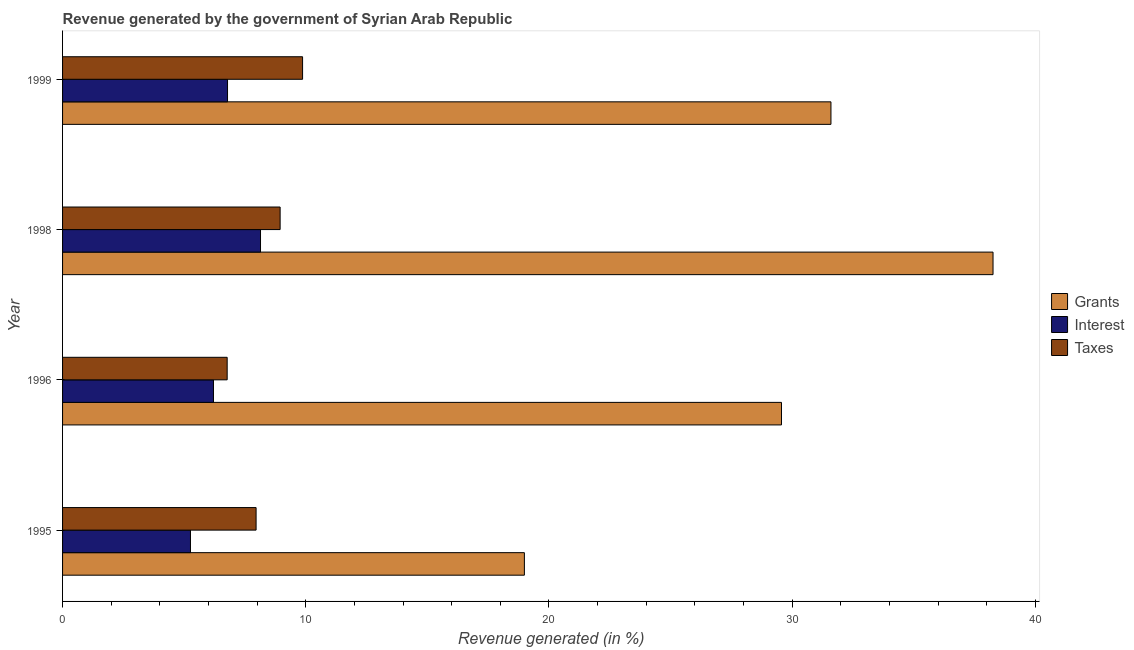Are the number of bars per tick equal to the number of legend labels?
Make the answer very short. Yes. What is the label of the 4th group of bars from the top?
Give a very brief answer. 1995. What is the percentage of revenue generated by taxes in 1998?
Make the answer very short. 8.95. Across all years, what is the maximum percentage of revenue generated by taxes?
Your answer should be compact. 9.87. Across all years, what is the minimum percentage of revenue generated by taxes?
Your answer should be compact. 6.77. In which year was the percentage of revenue generated by taxes maximum?
Give a very brief answer. 1999. What is the total percentage of revenue generated by interest in the graph?
Your answer should be compact. 26.39. What is the difference between the percentage of revenue generated by interest in 1996 and that in 1998?
Your answer should be compact. -1.93. What is the difference between the percentage of revenue generated by interest in 1995 and the percentage of revenue generated by grants in 1999?
Give a very brief answer. -26.34. What is the average percentage of revenue generated by taxes per year?
Your response must be concise. 8.39. In the year 1999, what is the difference between the percentage of revenue generated by interest and percentage of revenue generated by taxes?
Offer a very short reply. -3.09. What is the ratio of the percentage of revenue generated by taxes in 1995 to that in 1998?
Ensure brevity in your answer.  0.89. What is the difference between the highest and the second highest percentage of revenue generated by taxes?
Your answer should be compact. 0.92. What is the difference between the highest and the lowest percentage of revenue generated by interest?
Your response must be concise. 2.88. Is the sum of the percentage of revenue generated by interest in 1996 and 1999 greater than the maximum percentage of revenue generated by taxes across all years?
Provide a short and direct response. Yes. What does the 1st bar from the top in 1996 represents?
Keep it short and to the point. Taxes. What does the 1st bar from the bottom in 1996 represents?
Your response must be concise. Grants. Are all the bars in the graph horizontal?
Your answer should be very brief. Yes. How many years are there in the graph?
Offer a very short reply. 4. What is the difference between two consecutive major ticks on the X-axis?
Ensure brevity in your answer.  10. Are the values on the major ticks of X-axis written in scientific E-notation?
Your answer should be compact. No. Does the graph contain grids?
Your answer should be very brief. No. Where does the legend appear in the graph?
Offer a very short reply. Center right. How many legend labels are there?
Keep it short and to the point. 3. What is the title of the graph?
Make the answer very short. Revenue generated by the government of Syrian Arab Republic. What is the label or title of the X-axis?
Ensure brevity in your answer.  Revenue generated (in %). What is the Revenue generated (in %) in Grants in 1995?
Give a very brief answer. 18.99. What is the Revenue generated (in %) of Interest in 1995?
Offer a very short reply. 5.26. What is the Revenue generated (in %) of Taxes in 1995?
Keep it short and to the point. 7.96. What is the Revenue generated (in %) in Grants in 1996?
Provide a short and direct response. 29.56. What is the Revenue generated (in %) of Interest in 1996?
Give a very brief answer. 6.21. What is the Revenue generated (in %) in Taxes in 1996?
Your answer should be very brief. 6.77. What is the Revenue generated (in %) in Grants in 1998?
Ensure brevity in your answer.  38.26. What is the Revenue generated (in %) of Interest in 1998?
Your answer should be compact. 8.14. What is the Revenue generated (in %) of Taxes in 1998?
Provide a short and direct response. 8.95. What is the Revenue generated (in %) of Grants in 1999?
Your answer should be compact. 31.6. What is the Revenue generated (in %) of Interest in 1999?
Keep it short and to the point. 6.78. What is the Revenue generated (in %) in Taxes in 1999?
Offer a very short reply. 9.87. Across all years, what is the maximum Revenue generated (in %) of Grants?
Make the answer very short. 38.26. Across all years, what is the maximum Revenue generated (in %) in Interest?
Your answer should be compact. 8.14. Across all years, what is the maximum Revenue generated (in %) of Taxes?
Provide a short and direct response. 9.87. Across all years, what is the minimum Revenue generated (in %) of Grants?
Your answer should be compact. 18.99. Across all years, what is the minimum Revenue generated (in %) of Interest?
Your answer should be compact. 5.26. Across all years, what is the minimum Revenue generated (in %) in Taxes?
Your answer should be compact. 6.77. What is the total Revenue generated (in %) of Grants in the graph?
Make the answer very short. 118.41. What is the total Revenue generated (in %) of Interest in the graph?
Give a very brief answer. 26.39. What is the total Revenue generated (in %) in Taxes in the graph?
Ensure brevity in your answer.  33.54. What is the difference between the Revenue generated (in %) of Grants in 1995 and that in 1996?
Your answer should be compact. -10.57. What is the difference between the Revenue generated (in %) in Interest in 1995 and that in 1996?
Offer a terse response. -0.95. What is the difference between the Revenue generated (in %) in Taxes in 1995 and that in 1996?
Your response must be concise. 1.19. What is the difference between the Revenue generated (in %) in Grants in 1995 and that in 1998?
Your response must be concise. -19.27. What is the difference between the Revenue generated (in %) in Interest in 1995 and that in 1998?
Your answer should be compact. -2.88. What is the difference between the Revenue generated (in %) of Taxes in 1995 and that in 1998?
Offer a terse response. -0.99. What is the difference between the Revenue generated (in %) of Grants in 1995 and that in 1999?
Give a very brief answer. -12.61. What is the difference between the Revenue generated (in %) of Interest in 1995 and that in 1999?
Give a very brief answer. -1.52. What is the difference between the Revenue generated (in %) in Taxes in 1995 and that in 1999?
Give a very brief answer. -1.91. What is the difference between the Revenue generated (in %) in Grants in 1996 and that in 1998?
Ensure brevity in your answer.  -8.7. What is the difference between the Revenue generated (in %) of Interest in 1996 and that in 1998?
Your response must be concise. -1.93. What is the difference between the Revenue generated (in %) of Taxes in 1996 and that in 1998?
Offer a terse response. -2.18. What is the difference between the Revenue generated (in %) of Grants in 1996 and that in 1999?
Provide a short and direct response. -2.03. What is the difference between the Revenue generated (in %) of Interest in 1996 and that in 1999?
Make the answer very short. -0.58. What is the difference between the Revenue generated (in %) in Taxes in 1996 and that in 1999?
Your answer should be compact. -3.1. What is the difference between the Revenue generated (in %) in Grants in 1998 and that in 1999?
Offer a terse response. 6.66. What is the difference between the Revenue generated (in %) in Interest in 1998 and that in 1999?
Your response must be concise. 1.36. What is the difference between the Revenue generated (in %) in Taxes in 1998 and that in 1999?
Provide a succinct answer. -0.92. What is the difference between the Revenue generated (in %) of Grants in 1995 and the Revenue generated (in %) of Interest in 1996?
Provide a succinct answer. 12.79. What is the difference between the Revenue generated (in %) of Grants in 1995 and the Revenue generated (in %) of Taxes in 1996?
Offer a terse response. 12.22. What is the difference between the Revenue generated (in %) in Interest in 1995 and the Revenue generated (in %) in Taxes in 1996?
Keep it short and to the point. -1.51. What is the difference between the Revenue generated (in %) in Grants in 1995 and the Revenue generated (in %) in Interest in 1998?
Offer a terse response. 10.85. What is the difference between the Revenue generated (in %) of Grants in 1995 and the Revenue generated (in %) of Taxes in 1998?
Make the answer very short. 10.04. What is the difference between the Revenue generated (in %) in Interest in 1995 and the Revenue generated (in %) in Taxes in 1998?
Provide a short and direct response. -3.69. What is the difference between the Revenue generated (in %) in Grants in 1995 and the Revenue generated (in %) in Interest in 1999?
Your response must be concise. 12.21. What is the difference between the Revenue generated (in %) in Grants in 1995 and the Revenue generated (in %) in Taxes in 1999?
Provide a short and direct response. 9.12. What is the difference between the Revenue generated (in %) in Interest in 1995 and the Revenue generated (in %) in Taxes in 1999?
Your answer should be very brief. -4.61. What is the difference between the Revenue generated (in %) of Grants in 1996 and the Revenue generated (in %) of Interest in 1998?
Ensure brevity in your answer.  21.42. What is the difference between the Revenue generated (in %) in Grants in 1996 and the Revenue generated (in %) in Taxes in 1998?
Your answer should be compact. 20.62. What is the difference between the Revenue generated (in %) in Interest in 1996 and the Revenue generated (in %) in Taxes in 1998?
Offer a very short reply. -2.74. What is the difference between the Revenue generated (in %) of Grants in 1996 and the Revenue generated (in %) of Interest in 1999?
Ensure brevity in your answer.  22.78. What is the difference between the Revenue generated (in %) in Grants in 1996 and the Revenue generated (in %) in Taxes in 1999?
Your response must be concise. 19.69. What is the difference between the Revenue generated (in %) in Interest in 1996 and the Revenue generated (in %) in Taxes in 1999?
Provide a short and direct response. -3.66. What is the difference between the Revenue generated (in %) of Grants in 1998 and the Revenue generated (in %) of Interest in 1999?
Offer a very short reply. 31.48. What is the difference between the Revenue generated (in %) in Grants in 1998 and the Revenue generated (in %) in Taxes in 1999?
Your answer should be compact. 28.39. What is the difference between the Revenue generated (in %) of Interest in 1998 and the Revenue generated (in %) of Taxes in 1999?
Make the answer very short. -1.73. What is the average Revenue generated (in %) of Grants per year?
Keep it short and to the point. 29.6. What is the average Revenue generated (in %) in Interest per year?
Your answer should be very brief. 6.6. What is the average Revenue generated (in %) of Taxes per year?
Keep it short and to the point. 8.39. In the year 1995, what is the difference between the Revenue generated (in %) in Grants and Revenue generated (in %) in Interest?
Your response must be concise. 13.73. In the year 1995, what is the difference between the Revenue generated (in %) in Grants and Revenue generated (in %) in Taxes?
Offer a terse response. 11.03. In the year 1995, what is the difference between the Revenue generated (in %) in Interest and Revenue generated (in %) in Taxes?
Your answer should be compact. -2.7. In the year 1996, what is the difference between the Revenue generated (in %) in Grants and Revenue generated (in %) in Interest?
Provide a short and direct response. 23.36. In the year 1996, what is the difference between the Revenue generated (in %) of Grants and Revenue generated (in %) of Taxes?
Keep it short and to the point. 22.79. In the year 1996, what is the difference between the Revenue generated (in %) of Interest and Revenue generated (in %) of Taxes?
Keep it short and to the point. -0.56. In the year 1998, what is the difference between the Revenue generated (in %) of Grants and Revenue generated (in %) of Interest?
Give a very brief answer. 30.12. In the year 1998, what is the difference between the Revenue generated (in %) of Grants and Revenue generated (in %) of Taxes?
Provide a succinct answer. 29.31. In the year 1998, what is the difference between the Revenue generated (in %) of Interest and Revenue generated (in %) of Taxes?
Give a very brief answer. -0.81. In the year 1999, what is the difference between the Revenue generated (in %) of Grants and Revenue generated (in %) of Interest?
Ensure brevity in your answer.  24.81. In the year 1999, what is the difference between the Revenue generated (in %) of Grants and Revenue generated (in %) of Taxes?
Provide a short and direct response. 21.73. In the year 1999, what is the difference between the Revenue generated (in %) of Interest and Revenue generated (in %) of Taxes?
Keep it short and to the point. -3.09. What is the ratio of the Revenue generated (in %) of Grants in 1995 to that in 1996?
Make the answer very short. 0.64. What is the ratio of the Revenue generated (in %) in Interest in 1995 to that in 1996?
Give a very brief answer. 0.85. What is the ratio of the Revenue generated (in %) of Taxes in 1995 to that in 1996?
Your answer should be very brief. 1.18. What is the ratio of the Revenue generated (in %) of Grants in 1995 to that in 1998?
Provide a succinct answer. 0.5. What is the ratio of the Revenue generated (in %) in Interest in 1995 to that in 1998?
Give a very brief answer. 0.65. What is the ratio of the Revenue generated (in %) in Taxes in 1995 to that in 1998?
Provide a short and direct response. 0.89. What is the ratio of the Revenue generated (in %) in Grants in 1995 to that in 1999?
Your response must be concise. 0.6. What is the ratio of the Revenue generated (in %) of Interest in 1995 to that in 1999?
Your answer should be very brief. 0.78. What is the ratio of the Revenue generated (in %) in Taxes in 1995 to that in 1999?
Your answer should be compact. 0.81. What is the ratio of the Revenue generated (in %) in Grants in 1996 to that in 1998?
Your response must be concise. 0.77. What is the ratio of the Revenue generated (in %) of Interest in 1996 to that in 1998?
Ensure brevity in your answer.  0.76. What is the ratio of the Revenue generated (in %) in Taxes in 1996 to that in 1998?
Your answer should be very brief. 0.76. What is the ratio of the Revenue generated (in %) of Grants in 1996 to that in 1999?
Provide a succinct answer. 0.94. What is the ratio of the Revenue generated (in %) in Interest in 1996 to that in 1999?
Give a very brief answer. 0.91. What is the ratio of the Revenue generated (in %) of Taxes in 1996 to that in 1999?
Offer a terse response. 0.69. What is the ratio of the Revenue generated (in %) of Grants in 1998 to that in 1999?
Your answer should be very brief. 1.21. What is the ratio of the Revenue generated (in %) of Interest in 1998 to that in 1999?
Offer a very short reply. 1.2. What is the ratio of the Revenue generated (in %) of Taxes in 1998 to that in 1999?
Your response must be concise. 0.91. What is the difference between the highest and the second highest Revenue generated (in %) of Grants?
Give a very brief answer. 6.66. What is the difference between the highest and the second highest Revenue generated (in %) in Interest?
Your answer should be very brief. 1.36. What is the difference between the highest and the second highest Revenue generated (in %) in Taxes?
Make the answer very short. 0.92. What is the difference between the highest and the lowest Revenue generated (in %) in Grants?
Provide a succinct answer. 19.27. What is the difference between the highest and the lowest Revenue generated (in %) of Interest?
Your response must be concise. 2.88. What is the difference between the highest and the lowest Revenue generated (in %) in Taxes?
Your answer should be compact. 3.1. 